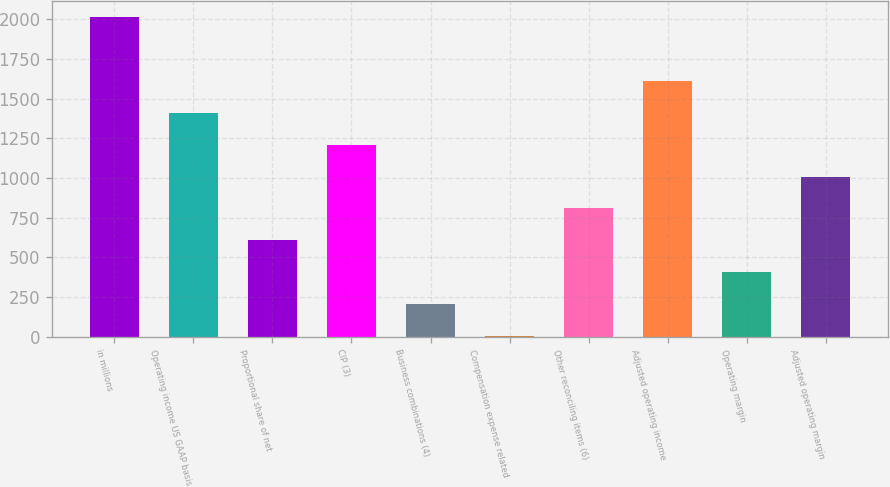Convert chart. <chart><loc_0><loc_0><loc_500><loc_500><bar_chart><fcel>in millions<fcel>Operating income US GAAP basis<fcel>Proportional share of net<fcel>CIP (3)<fcel>Business combinations (4)<fcel>Compensation expense related<fcel>Other reconciling items (6)<fcel>Adjusted operating income<fcel>Operating margin<fcel>Adjusted operating margin<nl><fcel>2015<fcel>1411.79<fcel>607.51<fcel>1210.72<fcel>205.37<fcel>4.3<fcel>808.58<fcel>1612.86<fcel>406.44<fcel>1009.65<nl></chart> 